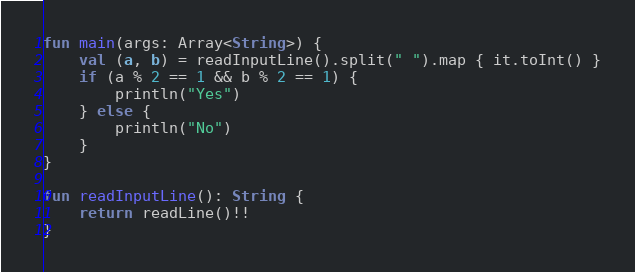<code> <loc_0><loc_0><loc_500><loc_500><_Kotlin_>fun main(args: Array<String>) {
    val (a, b) = readInputLine().split(" ").map { it.toInt() }
    if (a % 2 == 1 && b % 2 == 1) {
        println("Yes")
    } else {
        println("No")
    }
}

fun readInputLine(): String {
    return readLine()!!
}
</code> 